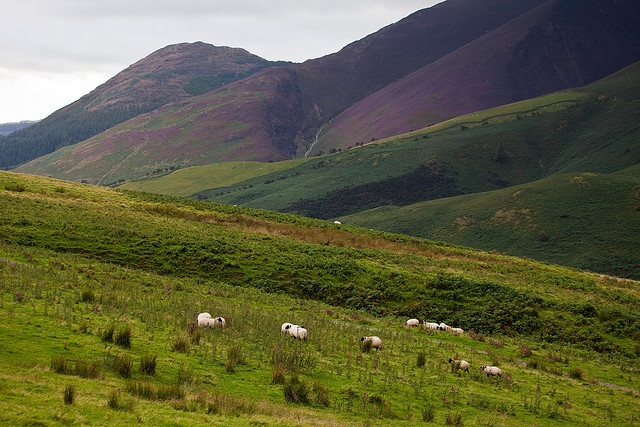Describe the objects in this image and their specific colors. I can see sheep in lightgray, olive, black, and darkgreen tones, sheep in lightgray, black, olive, and tan tones, sheep in lightgray, olive, and tan tones, sheep in lightgray, olive, black, and tan tones, and sheep in lightgray, tan, and black tones in this image. 